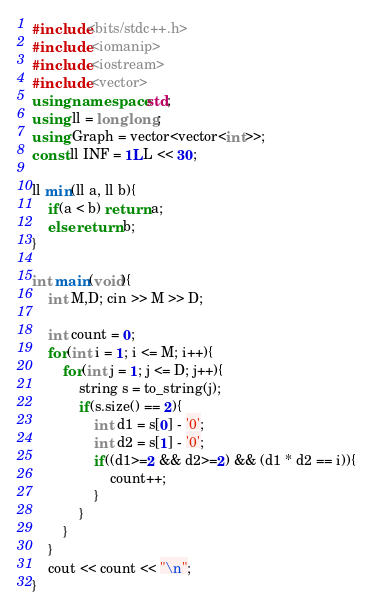Convert code to text. <code><loc_0><loc_0><loc_500><loc_500><_C++_>#include<bits/stdc++.h>
#include <iomanip>
#include <iostream>
#include <vector>
using namespace std;
using ll = long long;
using Graph = vector<vector<int>>;
const ll INF = 1LL << 30;

ll min(ll a, ll b){
    if(a < b) return a;
    else return b;
}

int main(void){
    int M,D; cin >> M >> D;
    
    int count = 0;
    for(int i = 1; i <= M; i++){
        for(int j = 1; j <= D; j++){
            string s = to_string(j);
            if(s.size() == 2){
                int d1 = s[0] - '0';
                int d2 = s[1] - '0';
                if((d1>=2 && d2>=2) && (d1 * d2 == i)){
                    count++;
                }
            }
        }
    }
    cout << count << "\n";
}
</code> 